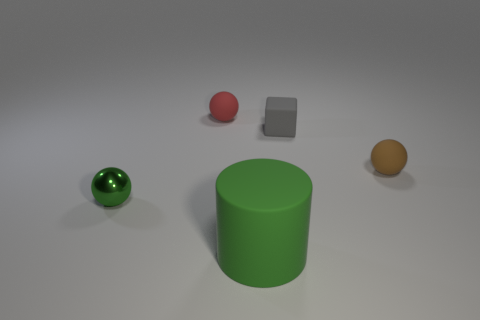Do the rubber cylinder and the small shiny sphere have the same color?
Provide a succinct answer. Yes. How many other things have the same shape as the red thing?
Make the answer very short. 2. There is a small object in front of the tiny ball to the right of the tiny red thing; what shape is it?
Your answer should be very brief. Sphere. There is a green object left of the green rubber cylinder; is its size the same as the small brown thing?
Give a very brief answer. Yes. There is a rubber object that is left of the small gray cube and on the right side of the tiny red matte object; what is its size?
Your response must be concise. Large. What number of metal cylinders have the same size as the red matte sphere?
Keep it short and to the point. 0. There is a tiny object left of the red thing; what number of objects are behind it?
Your answer should be very brief. 3. Does the tiny sphere that is in front of the brown rubber object have the same color as the large matte object?
Provide a short and direct response. Yes. There is a tiny matte ball that is on the left side of the rubber ball right of the gray matte object; are there any tiny green shiny balls that are in front of it?
Give a very brief answer. Yes. There is a object that is both behind the large cylinder and in front of the brown matte sphere; what is its shape?
Provide a succinct answer. Sphere. 